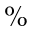<formula> <loc_0><loc_0><loc_500><loc_500>\%</formula> 